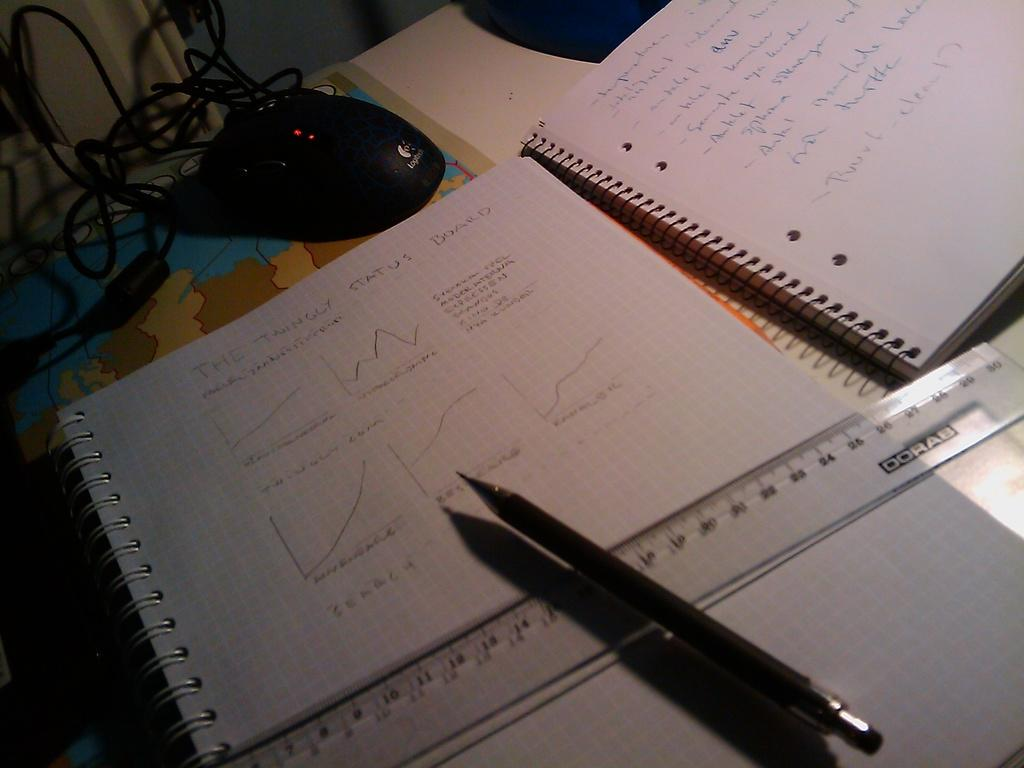What is the main object in the center of the image? There is a table in the center of the image. What items can be seen on the table? There is a book, a pen, a scale, and a mouse on the table. What might be used for writing in the image? The pen on the table can be used for writing. What device can be used for measuring weight in the image? The scale on the table can be used for measuring weight. What type of thunder can be heard in the image? There is no thunder present in the image; it is a still image with no sound. What type of care is being provided to the mouse in the image? There is no indication of any care being provided to the mouse in the image; it is simply a mouse sitting on the table. 